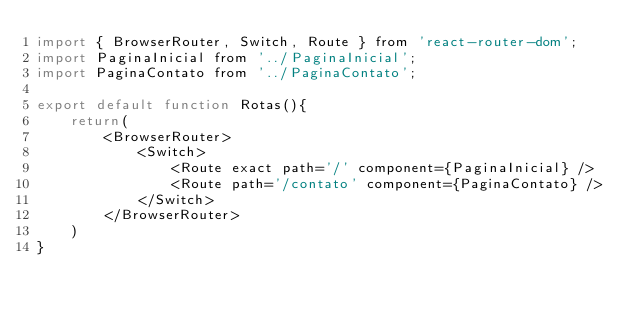Convert code to text. <code><loc_0><loc_0><loc_500><loc_500><_JavaScript_>import { BrowserRouter, Switch, Route } from 'react-router-dom';
import PaginaInicial from '../PaginaInicial';
import PaginaContato from '../PaginaContato';

export default function Rotas(){
    return(
        <BrowserRouter>
            <Switch>
                <Route exact path='/' component={PaginaInicial} />
                <Route path='/contato' component={PaginaContato} />
            </Switch>
        </BrowserRouter>
    )
} </code> 